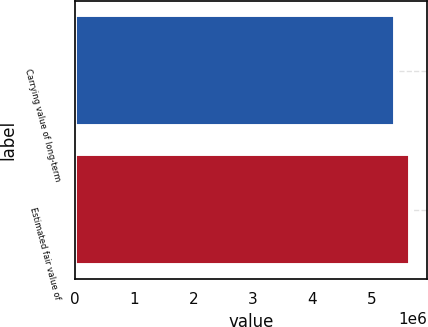Convert chart. <chart><loc_0><loc_0><loc_500><loc_500><bar_chart><fcel>Carrying value of long-term<fcel>Estimated fair value of<nl><fcel>5.38334e+06<fcel>5.64553e+06<nl></chart> 